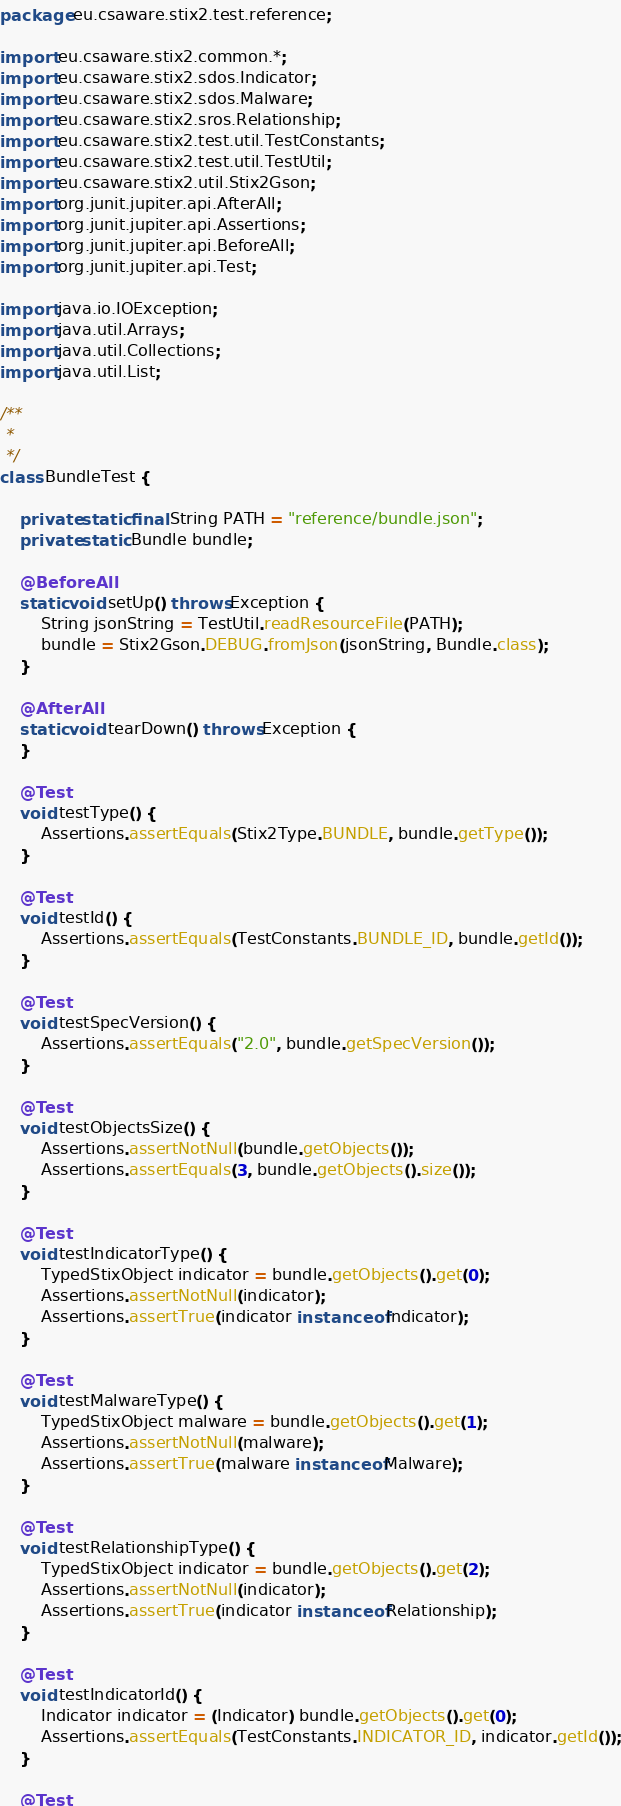Convert code to text. <code><loc_0><loc_0><loc_500><loc_500><_Java_>package eu.csaware.stix2.test.reference;

import eu.csaware.stix2.common.*;
import eu.csaware.stix2.sdos.Indicator;
import eu.csaware.stix2.sdos.Malware;
import eu.csaware.stix2.sros.Relationship;
import eu.csaware.stix2.test.util.TestConstants;
import eu.csaware.stix2.test.util.TestUtil;
import eu.csaware.stix2.util.Stix2Gson;
import org.junit.jupiter.api.AfterAll;
import org.junit.jupiter.api.Assertions;
import org.junit.jupiter.api.BeforeAll;
import org.junit.jupiter.api.Test;

import java.io.IOException;
import java.util.Arrays;
import java.util.Collections;
import java.util.List;

/**
 *
 */
class BundleTest {

    private static final String PATH = "reference/bundle.json";
    private static Bundle bundle;

    @BeforeAll
    static void setUp() throws Exception {
        String jsonString = TestUtil.readResourceFile(PATH);
        bundle = Stix2Gson.DEBUG.fromJson(jsonString, Bundle.class);
    }

    @AfterAll
    static void tearDown() throws Exception {
    }

    @Test
    void testType() {
        Assertions.assertEquals(Stix2Type.BUNDLE, bundle.getType());
    }

    @Test
    void testId() {
        Assertions.assertEquals(TestConstants.BUNDLE_ID, bundle.getId());
    }

    @Test
    void testSpecVersion() {
        Assertions.assertEquals("2.0", bundle.getSpecVersion());
    }

    @Test
    void testObjectsSize() {
        Assertions.assertNotNull(bundle.getObjects());
        Assertions.assertEquals(3, bundle.getObjects().size());
    }

    @Test
    void testIndicatorType() {
        TypedStixObject indicator = bundle.getObjects().get(0);
        Assertions.assertNotNull(indicator);
        Assertions.assertTrue(indicator instanceof Indicator);
    }

    @Test
    void testMalwareType() {
        TypedStixObject malware = bundle.getObjects().get(1);
        Assertions.assertNotNull(malware);
        Assertions.assertTrue(malware instanceof Malware);
    }

    @Test
    void testRelationshipType() {
        TypedStixObject indicator = bundle.getObjects().get(2);
        Assertions.assertNotNull(indicator);
        Assertions.assertTrue(indicator instanceof Relationship);
    }

    @Test
    void testIndicatorId() {
        Indicator indicator = (Indicator) bundle.getObjects().get(0);
        Assertions.assertEquals(TestConstants.INDICATOR_ID, indicator.getId());
    }

    @Test</code> 